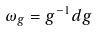<formula> <loc_0><loc_0><loc_500><loc_500>\omega _ { g } = g ^ { - 1 } d g</formula> 